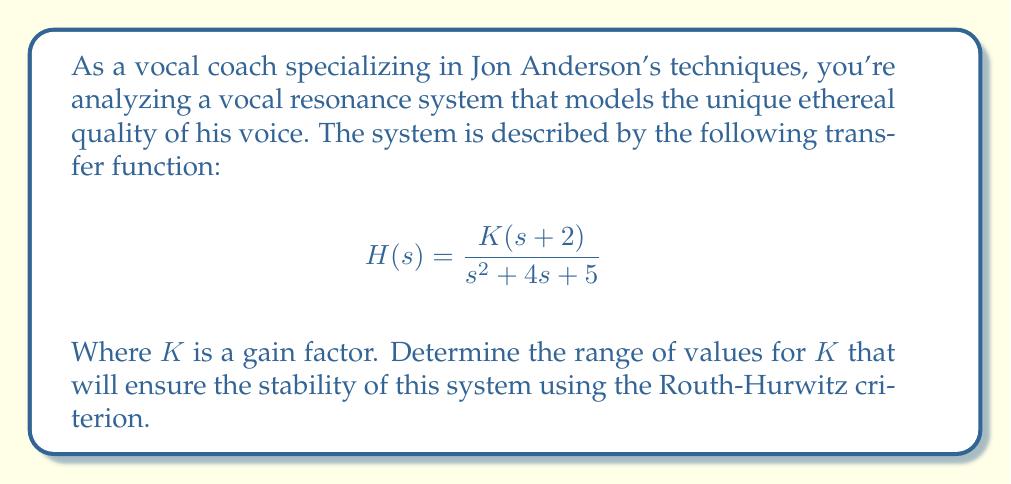Could you help me with this problem? To analyze the stability of this system using the Routh-Hurwitz criterion, we need to follow these steps:

1) First, we need to identify the characteristic equation of the system. The characteristic equation is the denominator of the transfer function set equal to zero:

   $$s^2 + 4s + 5 = 0$$

2) Now, we need to construct the Routh array. The Routh array for a second-order system looks like this:

   $$\begin{array}{c|c}
   s^2 & 1 & 5 \\
   s^1 & 4 & 0 \\
   s^0 & 5 & 
   \end{array}$$

3) For the system to be stable, all elements in the first column of the Routh array must be positive. In this case, they are all positive (1, 4, and 5), so the system is stable regardless of the value of $K$.

4) However, we need to consider the zeros of the system as well. The numerator of the transfer function is $K(s+2)$, which introduces a zero at $s = -2$.

5) For the overall system to be stable, this zero should be in the left half of the s-plane, which it is ($-2 < 0$).

6) The only remaining factor that could affect stability is the gain $K$. For a minimum-phase system like this one (all poles and zeros in the left half-plane), any positive value of $K$ will maintain stability.

Therefore, the system will be stable for any $K > 0$.
Answer: The system is stable for all $K > 0$. 